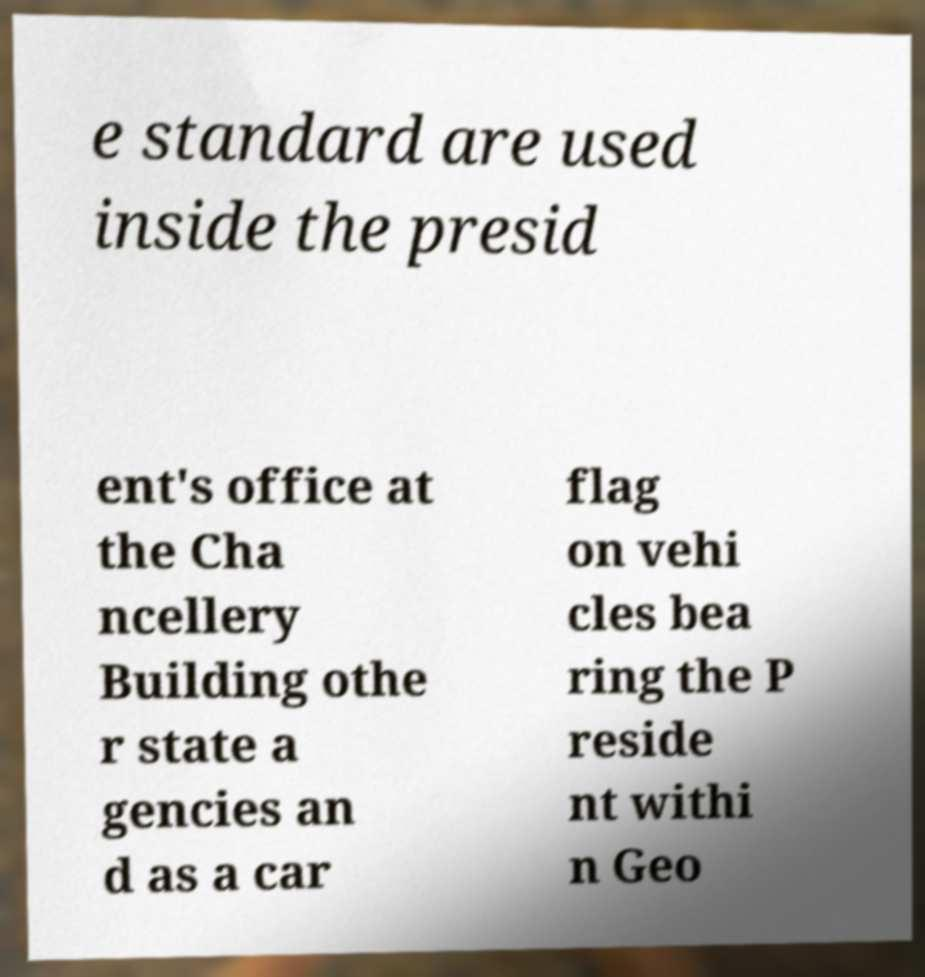Can you accurately transcribe the text from the provided image for me? e standard are used inside the presid ent's office at the Cha ncellery Building othe r state a gencies an d as a car flag on vehi cles bea ring the P reside nt withi n Geo 